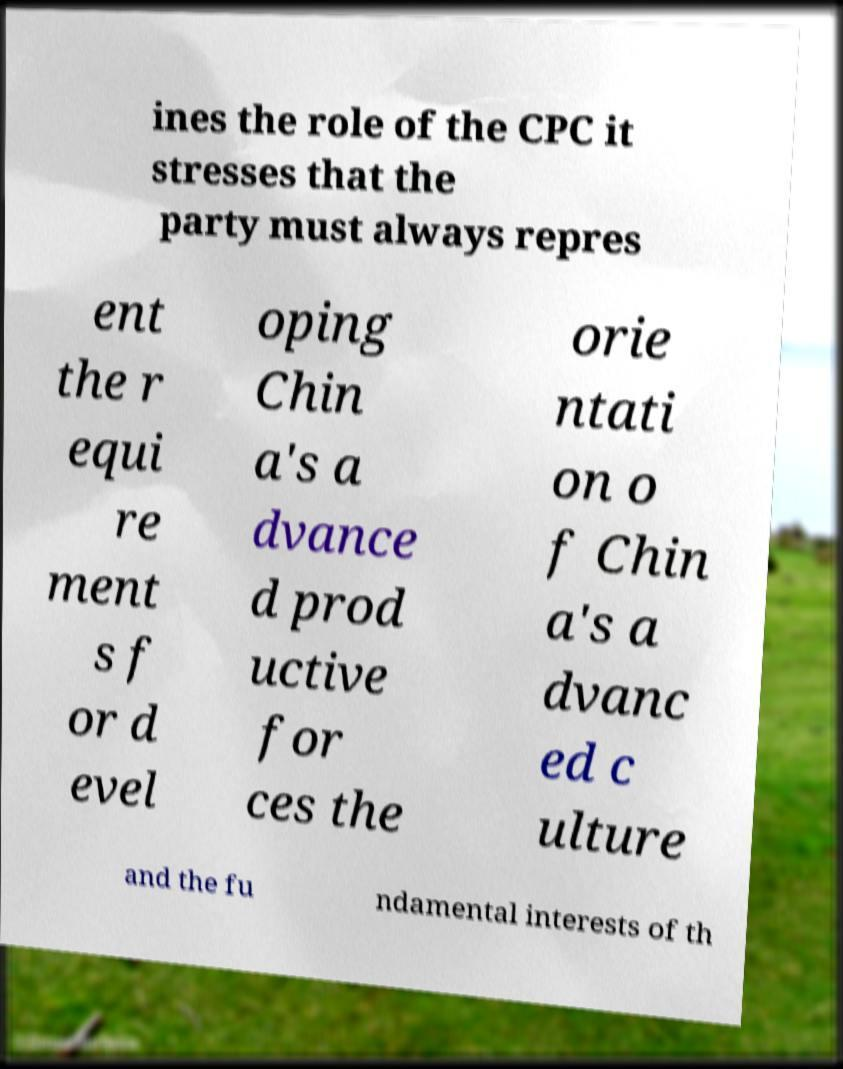There's text embedded in this image that I need extracted. Can you transcribe it verbatim? ines the role of the CPC it stresses that the party must always repres ent the r equi re ment s f or d evel oping Chin a's a dvance d prod uctive for ces the orie ntati on o f Chin a's a dvanc ed c ulture and the fu ndamental interests of th 